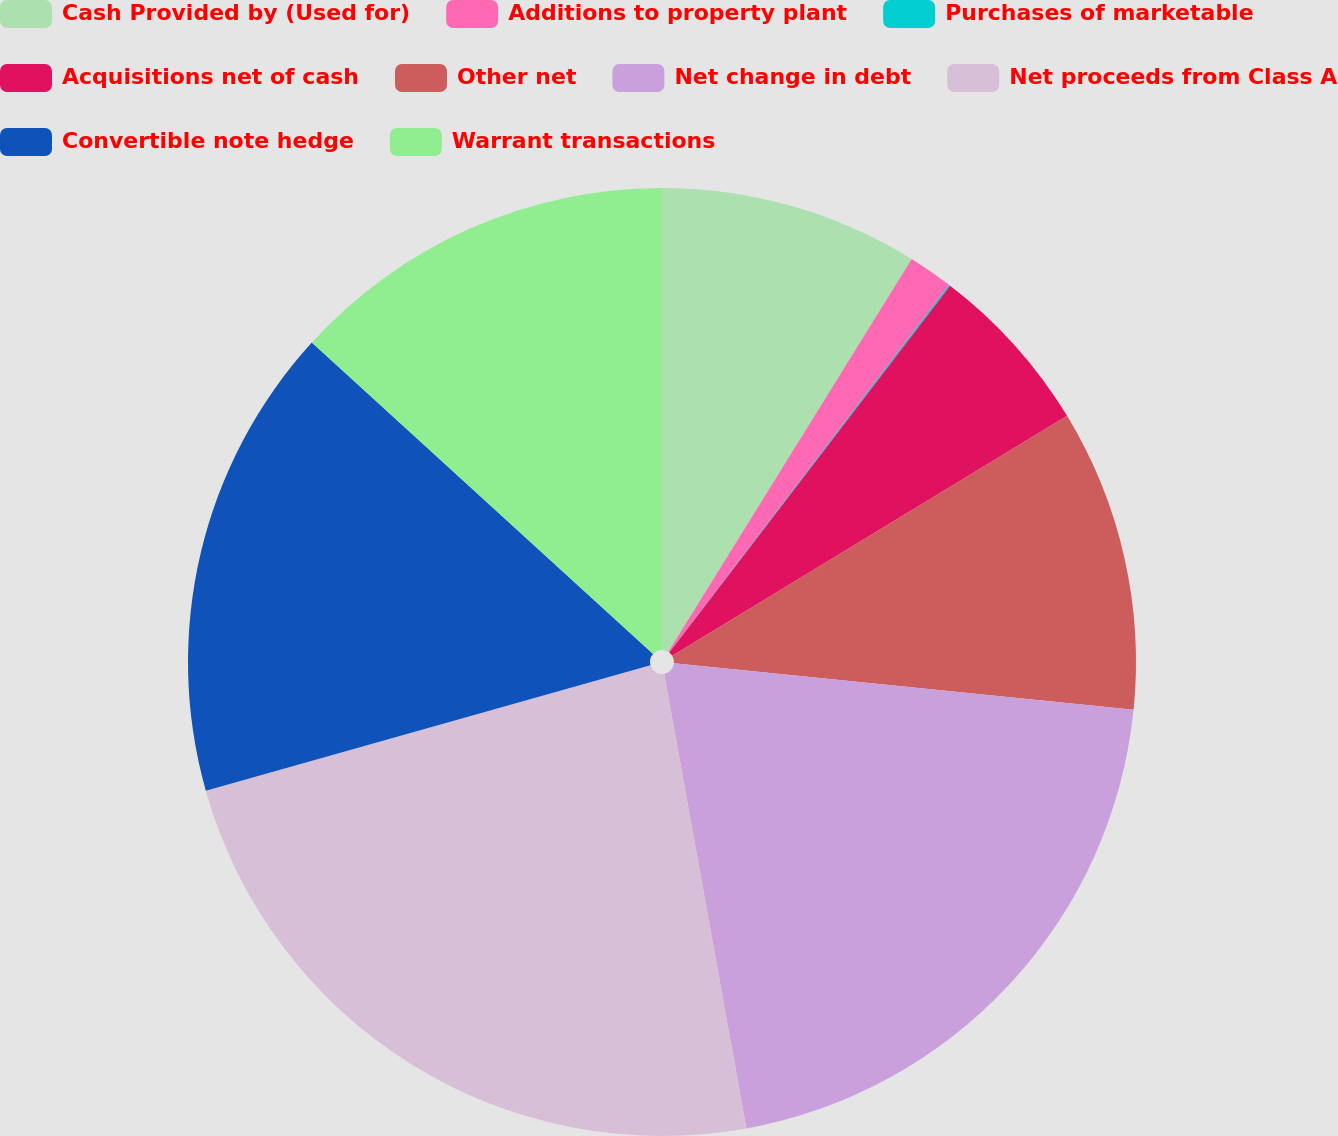<chart> <loc_0><loc_0><loc_500><loc_500><pie_chart><fcel>Cash Provided by (Used for)<fcel>Additions to property plant<fcel>Purchases of marketable<fcel>Acquisitions net of cash<fcel>Other net<fcel>Net change in debt<fcel>Net proceeds from Class A<fcel>Convertible note hedge<fcel>Warrant transactions<nl><fcel>8.83%<fcel>1.52%<fcel>0.05%<fcel>5.91%<fcel>10.3%<fcel>20.54%<fcel>23.47%<fcel>16.15%<fcel>13.23%<nl></chart> 